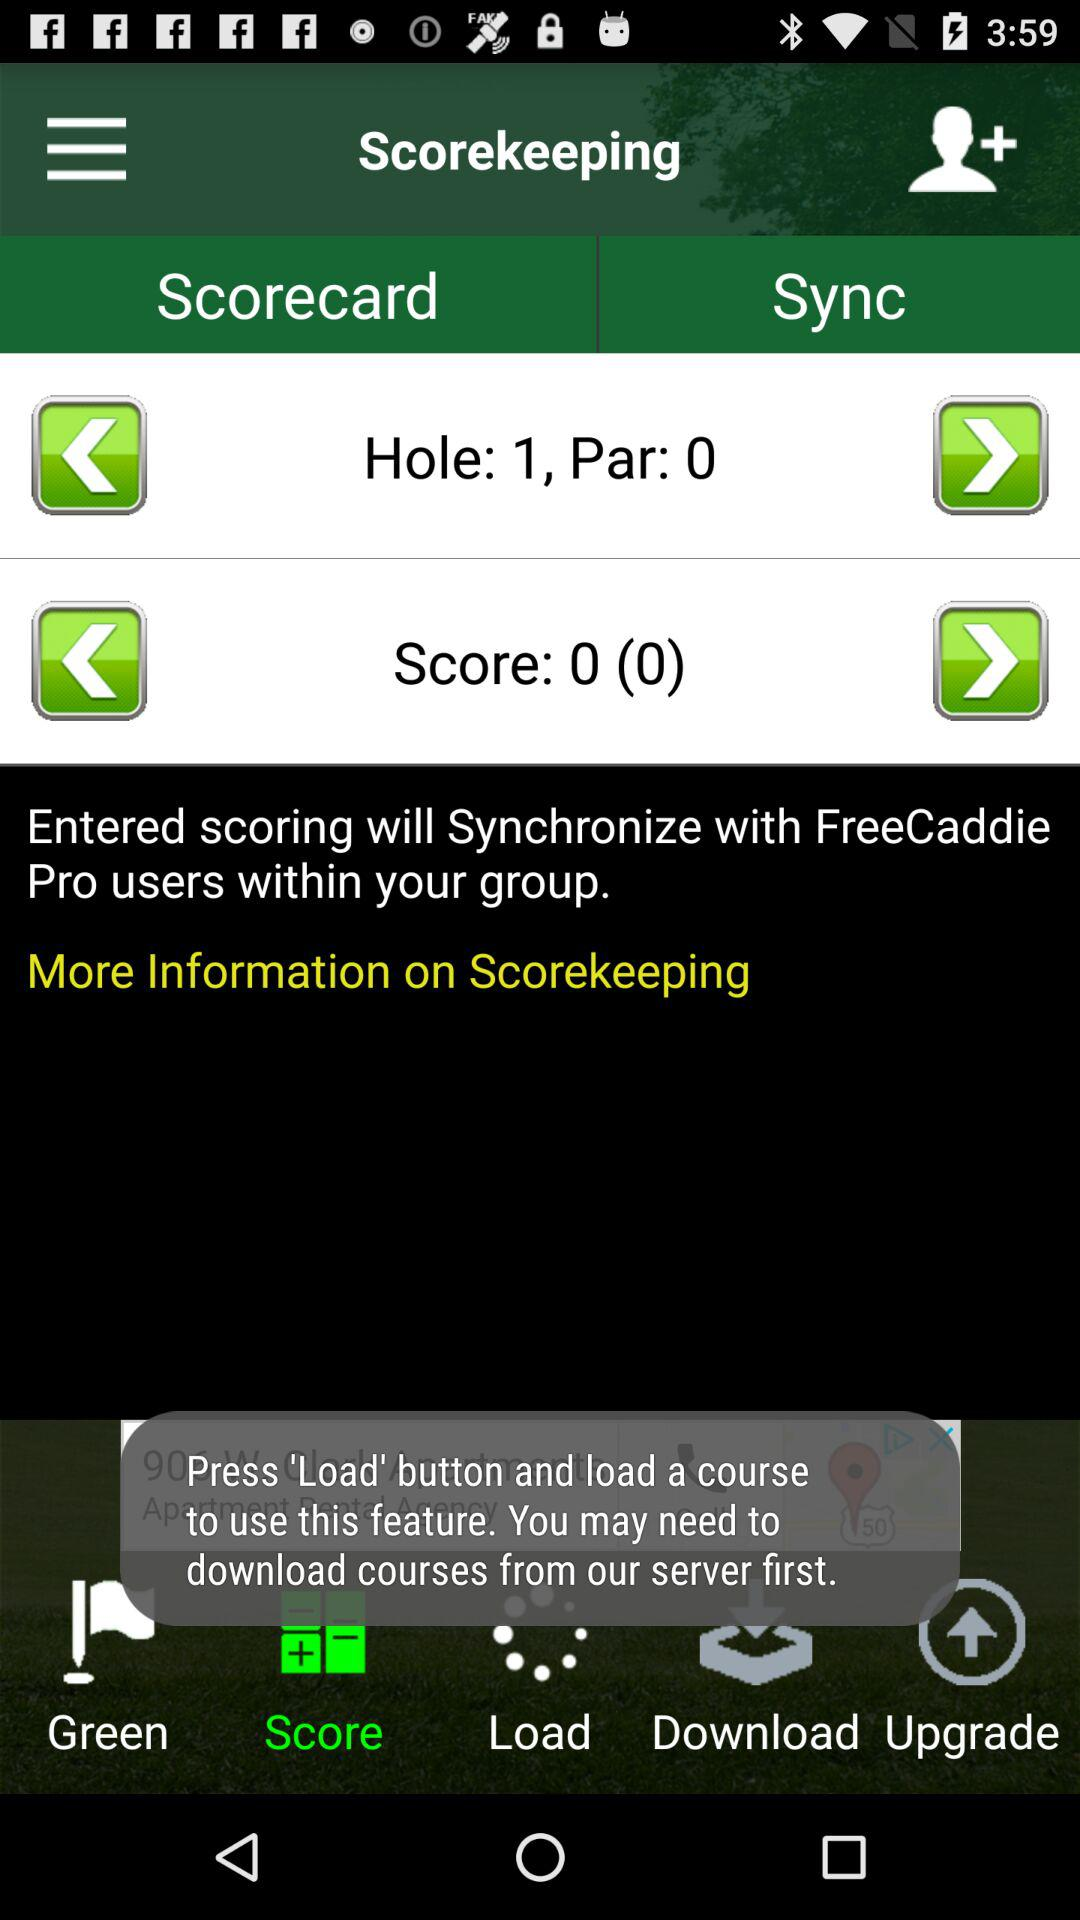What is the name of the application? The name of the application is "FreeCaddie". 